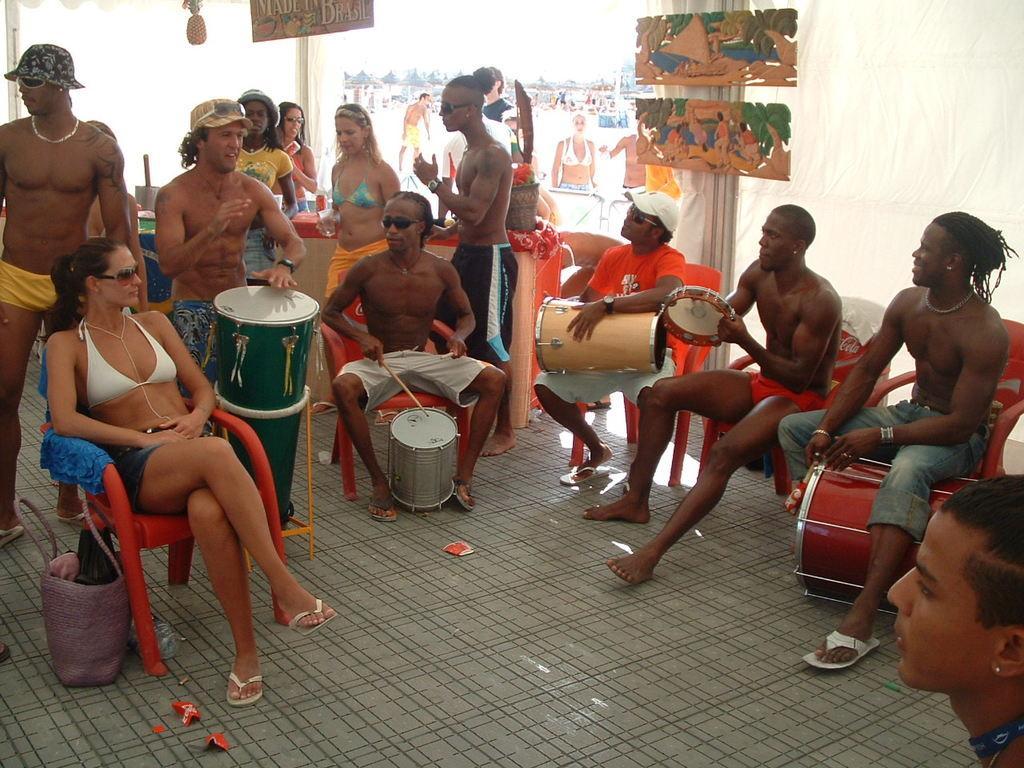In one or two sentences, can you explain what this image depicts? In this image there are group of persons who are beating drums sitting on the chairs and at the background there are paintings attached to the wall. 